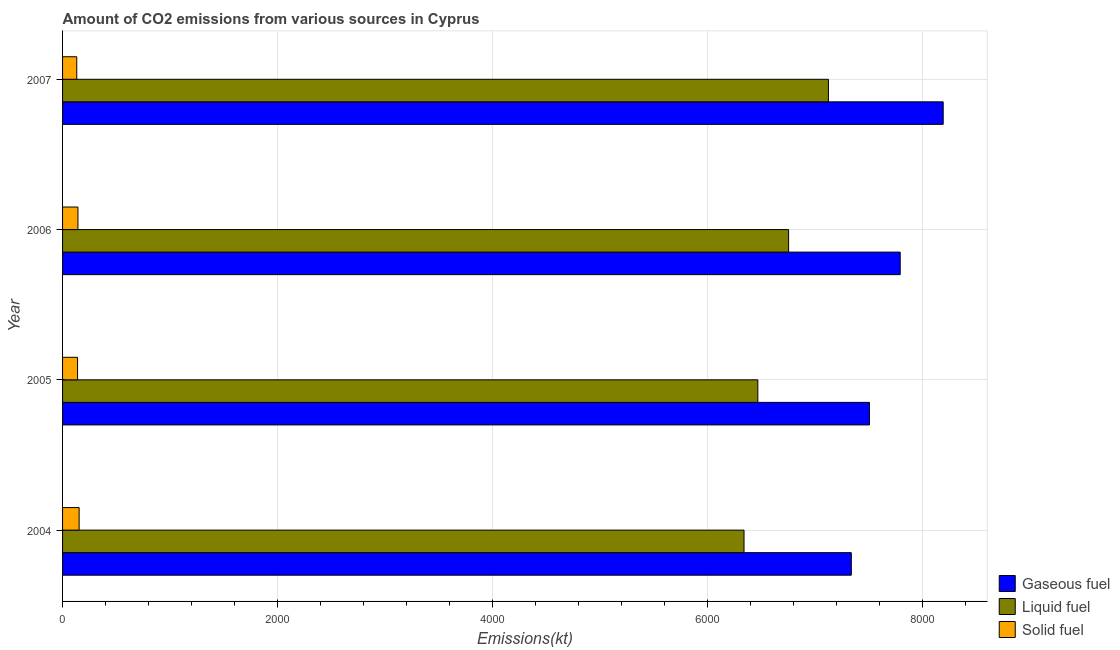How many different coloured bars are there?
Keep it short and to the point. 3. How many groups of bars are there?
Provide a succinct answer. 4. Are the number of bars per tick equal to the number of legend labels?
Provide a short and direct response. Yes. How many bars are there on the 1st tick from the top?
Provide a succinct answer. 3. What is the label of the 3rd group of bars from the top?
Offer a very short reply. 2005. In how many cases, is the number of bars for a given year not equal to the number of legend labels?
Make the answer very short. 0. What is the amount of co2 emissions from gaseous fuel in 2005?
Ensure brevity in your answer.  7502.68. Across all years, what is the maximum amount of co2 emissions from liquid fuel?
Offer a terse response. 7121.31. Across all years, what is the minimum amount of co2 emissions from gaseous fuel?
Ensure brevity in your answer.  7334. In which year was the amount of co2 emissions from liquid fuel minimum?
Keep it short and to the point. 2004. What is the total amount of co2 emissions from gaseous fuel in the graph?
Offer a very short reply. 3.08e+04. What is the difference between the amount of co2 emissions from solid fuel in 2004 and that in 2005?
Provide a short and direct response. 14.67. What is the difference between the amount of co2 emissions from solid fuel in 2006 and the amount of co2 emissions from gaseous fuel in 2004?
Provide a short and direct response. -7190.99. What is the average amount of co2 emissions from solid fuel per year?
Provide a short and direct response. 142.1. In the year 2004, what is the difference between the amount of co2 emissions from solid fuel and amount of co2 emissions from gaseous fuel?
Offer a very short reply. -7179.99. In how many years, is the amount of co2 emissions from liquid fuel greater than 7600 kt?
Your response must be concise. 0. Is the difference between the amount of co2 emissions from liquid fuel in 2005 and 2006 greater than the difference between the amount of co2 emissions from gaseous fuel in 2005 and 2006?
Provide a short and direct response. No. What is the difference between the highest and the second highest amount of co2 emissions from gaseous fuel?
Keep it short and to the point. 399.7. What is the difference between the highest and the lowest amount of co2 emissions from liquid fuel?
Make the answer very short. 784.74. In how many years, is the amount of co2 emissions from gaseous fuel greater than the average amount of co2 emissions from gaseous fuel taken over all years?
Your answer should be compact. 2. Is the sum of the amount of co2 emissions from liquid fuel in 2005 and 2007 greater than the maximum amount of co2 emissions from gaseous fuel across all years?
Offer a terse response. Yes. What does the 1st bar from the top in 2007 represents?
Your answer should be compact. Solid fuel. What does the 3rd bar from the bottom in 2007 represents?
Provide a succinct answer. Solid fuel. How many bars are there?
Ensure brevity in your answer.  12. Are all the bars in the graph horizontal?
Provide a succinct answer. Yes. How many years are there in the graph?
Your response must be concise. 4. Where does the legend appear in the graph?
Provide a short and direct response. Bottom right. How many legend labels are there?
Provide a short and direct response. 3. What is the title of the graph?
Your answer should be compact. Amount of CO2 emissions from various sources in Cyprus. What is the label or title of the X-axis?
Provide a short and direct response. Emissions(kt). What is the Emissions(kt) of Gaseous fuel in 2004?
Your response must be concise. 7334. What is the Emissions(kt) of Liquid fuel in 2004?
Offer a terse response. 6336.58. What is the Emissions(kt) of Solid fuel in 2004?
Provide a succinct answer. 154.01. What is the Emissions(kt) in Gaseous fuel in 2005?
Provide a short and direct response. 7502.68. What is the Emissions(kt) in Liquid fuel in 2005?
Ensure brevity in your answer.  6464.92. What is the Emissions(kt) of Solid fuel in 2005?
Provide a short and direct response. 139.35. What is the Emissions(kt) in Gaseous fuel in 2006?
Your answer should be compact. 7788.71. What is the Emissions(kt) in Liquid fuel in 2006?
Provide a succinct answer. 6750.95. What is the Emissions(kt) in Solid fuel in 2006?
Your answer should be very brief. 143.01. What is the Emissions(kt) of Gaseous fuel in 2007?
Ensure brevity in your answer.  8188.41. What is the Emissions(kt) of Liquid fuel in 2007?
Ensure brevity in your answer.  7121.31. What is the Emissions(kt) in Solid fuel in 2007?
Your answer should be very brief. 132.01. Across all years, what is the maximum Emissions(kt) of Gaseous fuel?
Provide a succinct answer. 8188.41. Across all years, what is the maximum Emissions(kt) of Liquid fuel?
Provide a succinct answer. 7121.31. Across all years, what is the maximum Emissions(kt) of Solid fuel?
Give a very brief answer. 154.01. Across all years, what is the minimum Emissions(kt) of Gaseous fuel?
Your answer should be very brief. 7334. Across all years, what is the minimum Emissions(kt) in Liquid fuel?
Give a very brief answer. 6336.58. Across all years, what is the minimum Emissions(kt) of Solid fuel?
Keep it short and to the point. 132.01. What is the total Emissions(kt) in Gaseous fuel in the graph?
Offer a terse response. 3.08e+04. What is the total Emissions(kt) in Liquid fuel in the graph?
Your answer should be compact. 2.67e+04. What is the total Emissions(kt) in Solid fuel in the graph?
Your answer should be compact. 568.38. What is the difference between the Emissions(kt) in Gaseous fuel in 2004 and that in 2005?
Your answer should be very brief. -168.68. What is the difference between the Emissions(kt) in Liquid fuel in 2004 and that in 2005?
Offer a terse response. -128.34. What is the difference between the Emissions(kt) of Solid fuel in 2004 and that in 2005?
Offer a very short reply. 14.67. What is the difference between the Emissions(kt) of Gaseous fuel in 2004 and that in 2006?
Keep it short and to the point. -454.71. What is the difference between the Emissions(kt) in Liquid fuel in 2004 and that in 2006?
Ensure brevity in your answer.  -414.37. What is the difference between the Emissions(kt) in Solid fuel in 2004 and that in 2006?
Keep it short and to the point. 11. What is the difference between the Emissions(kt) of Gaseous fuel in 2004 and that in 2007?
Ensure brevity in your answer.  -854.41. What is the difference between the Emissions(kt) of Liquid fuel in 2004 and that in 2007?
Keep it short and to the point. -784.74. What is the difference between the Emissions(kt) of Solid fuel in 2004 and that in 2007?
Keep it short and to the point. 22. What is the difference between the Emissions(kt) of Gaseous fuel in 2005 and that in 2006?
Offer a terse response. -286.03. What is the difference between the Emissions(kt) in Liquid fuel in 2005 and that in 2006?
Provide a succinct answer. -286.03. What is the difference between the Emissions(kt) of Solid fuel in 2005 and that in 2006?
Provide a succinct answer. -3.67. What is the difference between the Emissions(kt) in Gaseous fuel in 2005 and that in 2007?
Give a very brief answer. -685.73. What is the difference between the Emissions(kt) in Liquid fuel in 2005 and that in 2007?
Provide a short and direct response. -656.39. What is the difference between the Emissions(kt) of Solid fuel in 2005 and that in 2007?
Your answer should be compact. 7.33. What is the difference between the Emissions(kt) of Gaseous fuel in 2006 and that in 2007?
Give a very brief answer. -399.7. What is the difference between the Emissions(kt) of Liquid fuel in 2006 and that in 2007?
Keep it short and to the point. -370.37. What is the difference between the Emissions(kt) of Solid fuel in 2006 and that in 2007?
Your answer should be very brief. 11. What is the difference between the Emissions(kt) in Gaseous fuel in 2004 and the Emissions(kt) in Liquid fuel in 2005?
Your answer should be very brief. 869.08. What is the difference between the Emissions(kt) of Gaseous fuel in 2004 and the Emissions(kt) of Solid fuel in 2005?
Provide a succinct answer. 7194.65. What is the difference between the Emissions(kt) of Liquid fuel in 2004 and the Emissions(kt) of Solid fuel in 2005?
Give a very brief answer. 6197.23. What is the difference between the Emissions(kt) of Gaseous fuel in 2004 and the Emissions(kt) of Liquid fuel in 2006?
Provide a short and direct response. 583.05. What is the difference between the Emissions(kt) of Gaseous fuel in 2004 and the Emissions(kt) of Solid fuel in 2006?
Provide a short and direct response. 7190.99. What is the difference between the Emissions(kt) of Liquid fuel in 2004 and the Emissions(kt) of Solid fuel in 2006?
Give a very brief answer. 6193.56. What is the difference between the Emissions(kt) of Gaseous fuel in 2004 and the Emissions(kt) of Liquid fuel in 2007?
Offer a terse response. 212.69. What is the difference between the Emissions(kt) of Gaseous fuel in 2004 and the Emissions(kt) of Solid fuel in 2007?
Offer a very short reply. 7201.99. What is the difference between the Emissions(kt) of Liquid fuel in 2004 and the Emissions(kt) of Solid fuel in 2007?
Ensure brevity in your answer.  6204.56. What is the difference between the Emissions(kt) of Gaseous fuel in 2005 and the Emissions(kt) of Liquid fuel in 2006?
Your answer should be compact. 751.74. What is the difference between the Emissions(kt) of Gaseous fuel in 2005 and the Emissions(kt) of Solid fuel in 2006?
Keep it short and to the point. 7359.67. What is the difference between the Emissions(kt) of Liquid fuel in 2005 and the Emissions(kt) of Solid fuel in 2006?
Keep it short and to the point. 6321.91. What is the difference between the Emissions(kt) of Gaseous fuel in 2005 and the Emissions(kt) of Liquid fuel in 2007?
Offer a very short reply. 381.37. What is the difference between the Emissions(kt) of Gaseous fuel in 2005 and the Emissions(kt) of Solid fuel in 2007?
Provide a short and direct response. 7370.67. What is the difference between the Emissions(kt) in Liquid fuel in 2005 and the Emissions(kt) in Solid fuel in 2007?
Give a very brief answer. 6332.91. What is the difference between the Emissions(kt) of Gaseous fuel in 2006 and the Emissions(kt) of Liquid fuel in 2007?
Provide a short and direct response. 667.39. What is the difference between the Emissions(kt) in Gaseous fuel in 2006 and the Emissions(kt) in Solid fuel in 2007?
Keep it short and to the point. 7656.7. What is the difference between the Emissions(kt) in Liquid fuel in 2006 and the Emissions(kt) in Solid fuel in 2007?
Keep it short and to the point. 6618.94. What is the average Emissions(kt) in Gaseous fuel per year?
Offer a terse response. 7703.45. What is the average Emissions(kt) in Liquid fuel per year?
Keep it short and to the point. 6668.44. What is the average Emissions(kt) in Solid fuel per year?
Your answer should be very brief. 142.1. In the year 2004, what is the difference between the Emissions(kt) in Gaseous fuel and Emissions(kt) in Liquid fuel?
Your answer should be compact. 997.42. In the year 2004, what is the difference between the Emissions(kt) of Gaseous fuel and Emissions(kt) of Solid fuel?
Your answer should be very brief. 7179.99. In the year 2004, what is the difference between the Emissions(kt) of Liquid fuel and Emissions(kt) of Solid fuel?
Provide a short and direct response. 6182.56. In the year 2005, what is the difference between the Emissions(kt) in Gaseous fuel and Emissions(kt) in Liquid fuel?
Provide a succinct answer. 1037.76. In the year 2005, what is the difference between the Emissions(kt) of Gaseous fuel and Emissions(kt) of Solid fuel?
Provide a short and direct response. 7363.34. In the year 2005, what is the difference between the Emissions(kt) in Liquid fuel and Emissions(kt) in Solid fuel?
Provide a short and direct response. 6325.57. In the year 2006, what is the difference between the Emissions(kt) of Gaseous fuel and Emissions(kt) of Liquid fuel?
Provide a short and direct response. 1037.76. In the year 2006, what is the difference between the Emissions(kt) of Gaseous fuel and Emissions(kt) of Solid fuel?
Keep it short and to the point. 7645.69. In the year 2006, what is the difference between the Emissions(kt) of Liquid fuel and Emissions(kt) of Solid fuel?
Your response must be concise. 6607.93. In the year 2007, what is the difference between the Emissions(kt) in Gaseous fuel and Emissions(kt) in Liquid fuel?
Provide a short and direct response. 1067.1. In the year 2007, what is the difference between the Emissions(kt) in Gaseous fuel and Emissions(kt) in Solid fuel?
Make the answer very short. 8056.4. In the year 2007, what is the difference between the Emissions(kt) of Liquid fuel and Emissions(kt) of Solid fuel?
Offer a very short reply. 6989.3. What is the ratio of the Emissions(kt) in Gaseous fuel in 2004 to that in 2005?
Offer a very short reply. 0.98. What is the ratio of the Emissions(kt) of Liquid fuel in 2004 to that in 2005?
Give a very brief answer. 0.98. What is the ratio of the Emissions(kt) of Solid fuel in 2004 to that in 2005?
Make the answer very short. 1.11. What is the ratio of the Emissions(kt) of Gaseous fuel in 2004 to that in 2006?
Provide a succinct answer. 0.94. What is the ratio of the Emissions(kt) of Liquid fuel in 2004 to that in 2006?
Offer a very short reply. 0.94. What is the ratio of the Emissions(kt) in Solid fuel in 2004 to that in 2006?
Your response must be concise. 1.08. What is the ratio of the Emissions(kt) of Gaseous fuel in 2004 to that in 2007?
Ensure brevity in your answer.  0.9. What is the ratio of the Emissions(kt) in Liquid fuel in 2004 to that in 2007?
Your answer should be very brief. 0.89. What is the ratio of the Emissions(kt) in Solid fuel in 2004 to that in 2007?
Your answer should be compact. 1.17. What is the ratio of the Emissions(kt) of Gaseous fuel in 2005 to that in 2006?
Offer a terse response. 0.96. What is the ratio of the Emissions(kt) in Liquid fuel in 2005 to that in 2006?
Offer a terse response. 0.96. What is the ratio of the Emissions(kt) of Solid fuel in 2005 to that in 2006?
Offer a terse response. 0.97. What is the ratio of the Emissions(kt) of Gaseous fuel in 2005 to that in 2007?
Provide a short and direct response. 0.92. What is the ratio of the Emissions(kt) of Liquid fuel in 2005 to that in 2007?
Your answer should be very brief. 0.91. What is the ratio of the Emissions(kt) of Solid fuel in 2005 to that in 2007?
Offer a very short reply. 1.06. What is the ratio of the Emissions(kt) in Gaseous fuel in 2006 to that in 2007?
Your response must be concise. 0.95. What is the ratio of the Emissions(kt) in Liquid fuel in 2006 to that in 2007?
Give a very brief answer. 0.95. What is the ratio of the Emissions(kt) of Solid fuel in 2006 to that in 2007?
Your answer should be compact. 1.08. What is the difference between the highest and the second highest Emissions(kt) in Gaseous fuel?
Ensure brevity in your answer.  399.7. What is the difference between the highest and the second highest Emissions(kt) of Liquid fuel?
Provide a succinct answer. 370.37. What is the difference between the highest and the second highest Emissions(kt) of Solid fuel?
Offer a terse response. 11. What is the difference between the highest and the lowest Emissions(kt) in Gaseous fuel?
Provide a succinct answer. 854.41. What is the difference between the highest and the lowest Emissions(kt) in Liquid fuel?
Your response must be concise. 784.74. What is the difference between the highest and the lowest Emissions(kt) of Solid fuel?
Your answer should be compact. 22. 